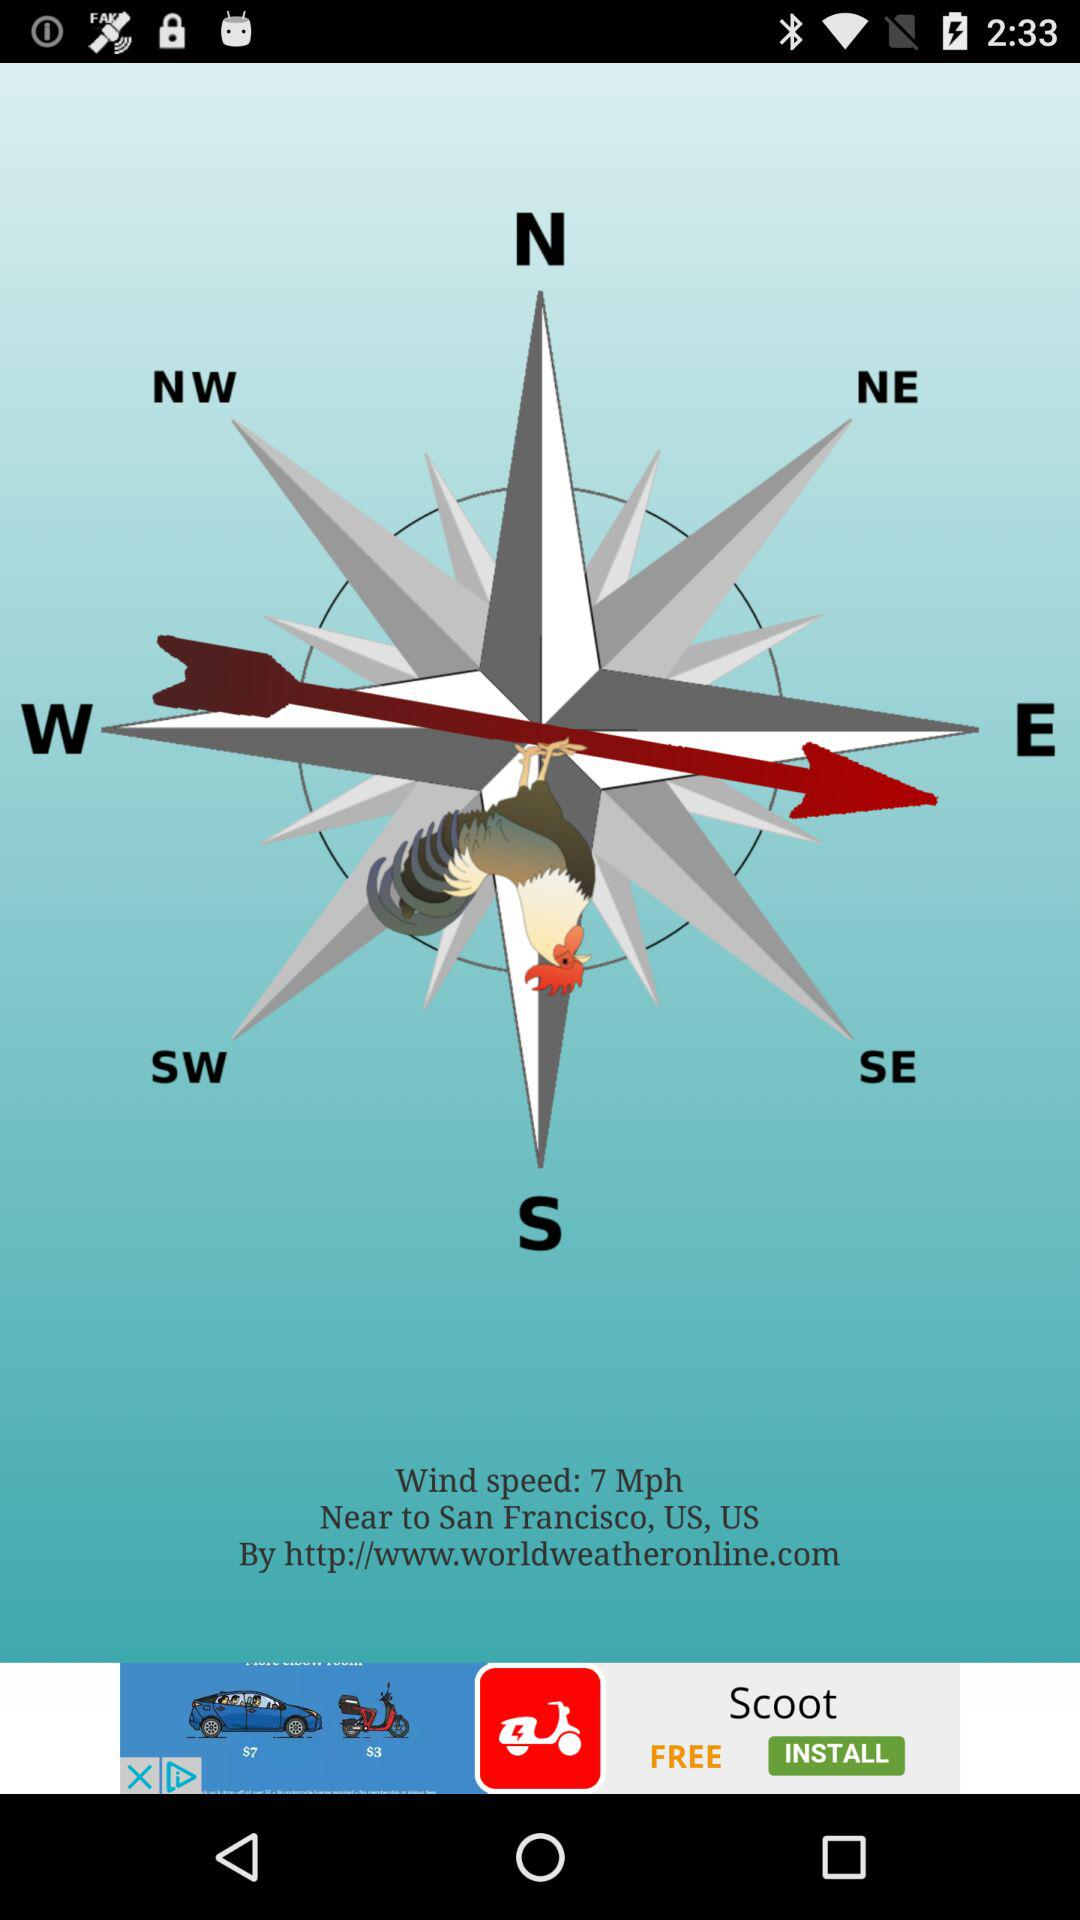What is the given location? The given location is San Francisco, US, US. 